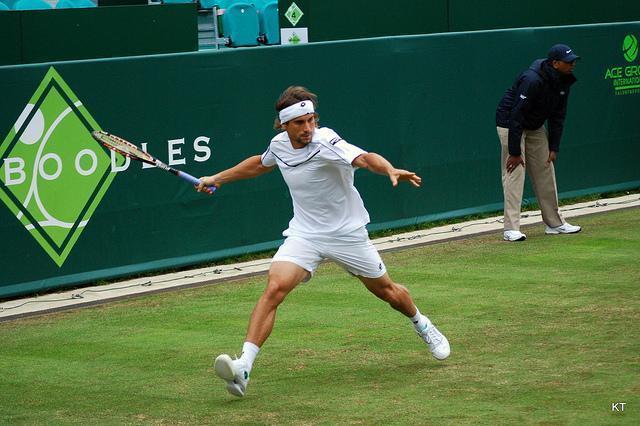How many seats can you see?
Give a very brief answer. 2. How many people can be seen?
Give a very brief answer. 2. How many red cars are driving on the road?
Give a very brief answer. 0. 